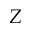<formula> <loc_0><loc_0><loc_500><loc_500>Z</formula> 